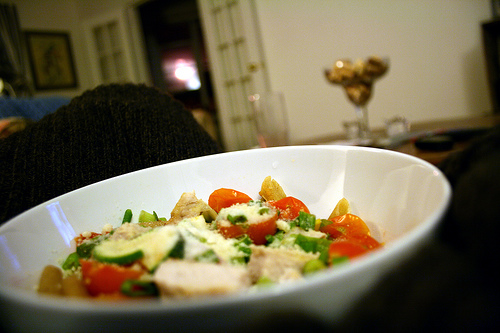<image>
Is there a food on the bowel? Yes. Looking at the image, I can see the food is positioned on top of the bowel, with the bowel providing support. Is the food behind the plate? No. The food is not behind the plate. From this viewpoint, the food appears to be positioned elsewhere in the scene. 